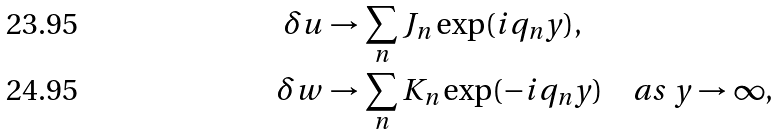Convert formula to latex. <formula><loc_0><loc_0><loc_500><loc_500>\delta u & \to \sum _ { n } J _ { n } \exp ( i q _ { n } y ) , \\ \delta w & \to \sum _ { n } K _ { n } \exp ( - i q _ { n } y ) \quad a s \ y \to \infty ,</formula> 